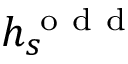Convert formula to latex. <formula><loc_0><loc_0><loc_500><loc_500>h _ { s } ^ { o d d }</formula> 